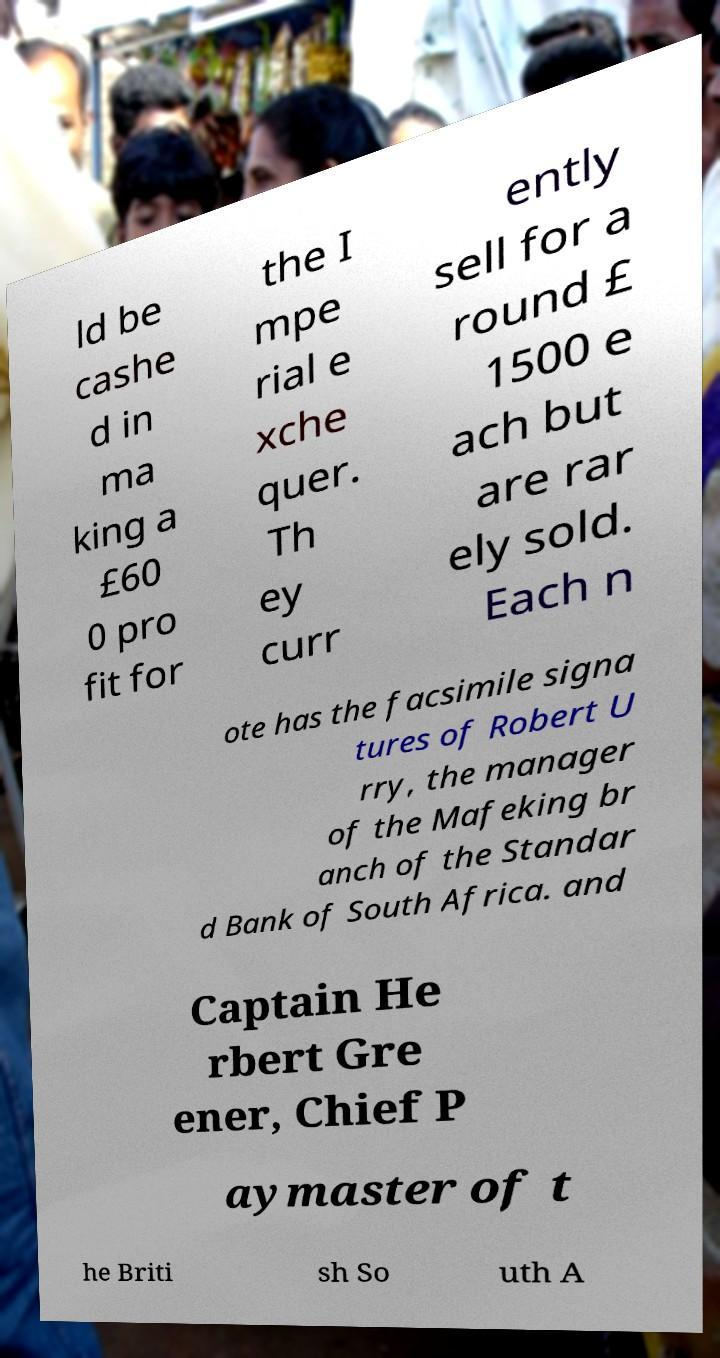There's text embedded in this image that I need extracted. Can you transcribe it verbatim? ld be cashe d in ma king a £60 0 pro fit for the I mpe rial e xche quer. Th ey curr ently sell for a round £ 1500 e ach but are rar ely sold. Each n ote has the facsimile signa tures of Robert U rry, the manager of the Mafeking br anch of the Standar d Bank of South Africa. and Captain He rbert Gre ener, Chief P aymaster of t he Briti sh So uth A 